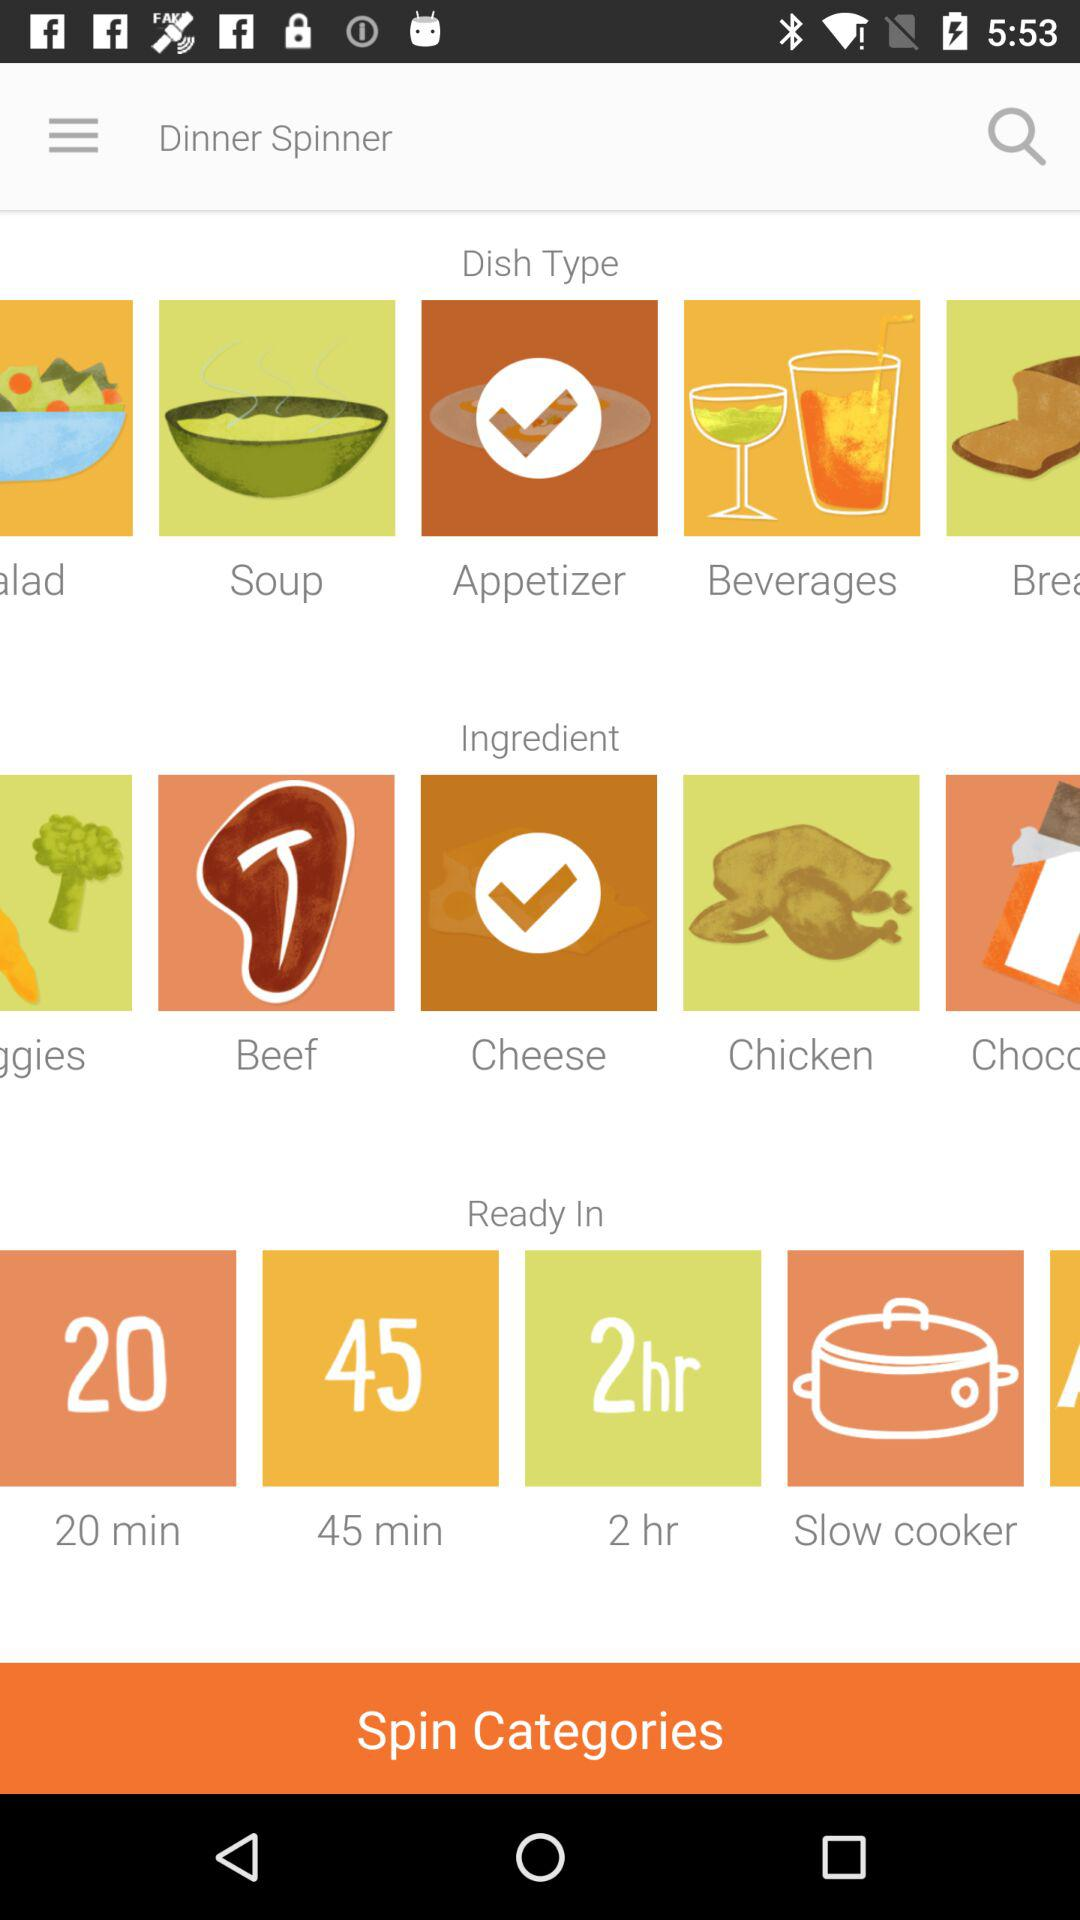What is the selected dish type? The selected dish type is "Appetizer". 